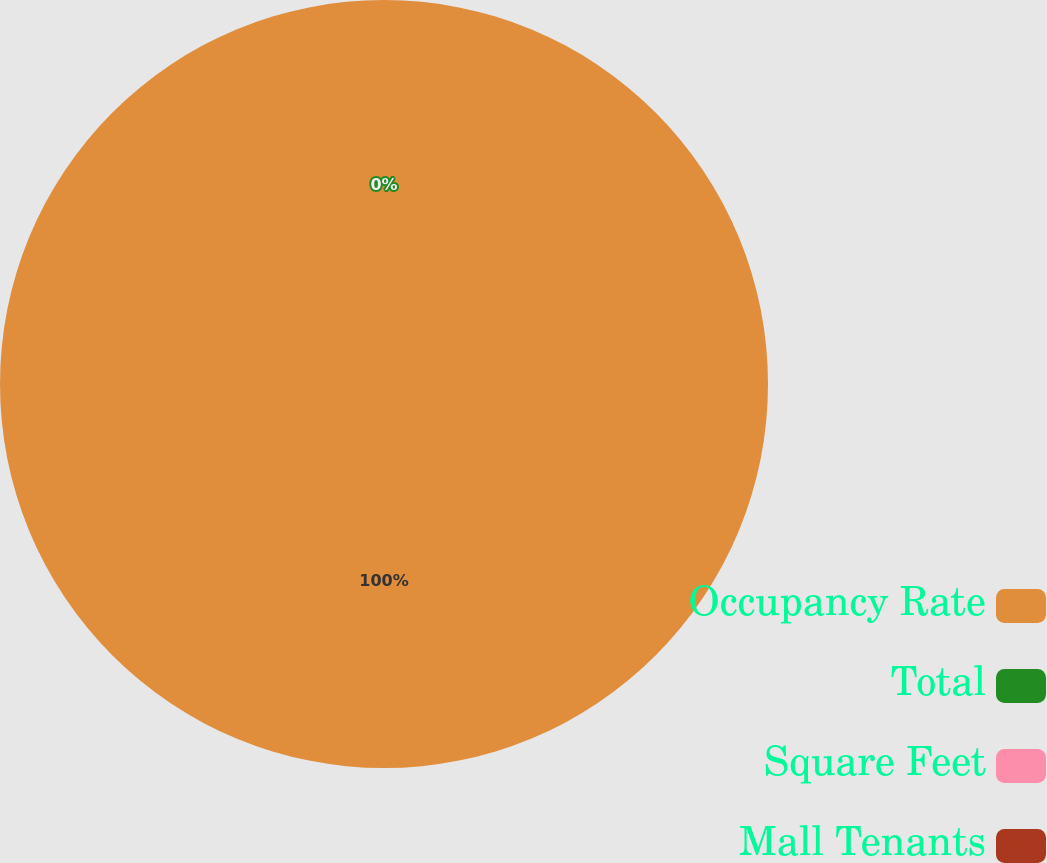Convert chart. <chart><loc_0><loc_0><loc_500><loc_500><pie_chart><fcel>Occupancy Rate<fcel>Total<fcel>Square Feet<fcel>Mall Tenants<nl><fcel>100.0%<fcel>0.0%<fcel>0.0%<fcel>0.0%<nl></chart> 